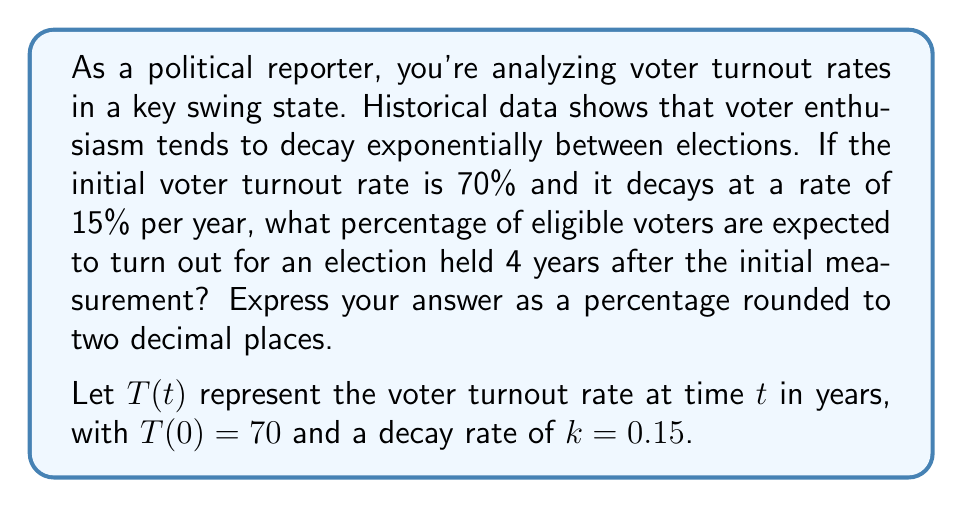Help me with this question. To solve this problem, we'll use the exponential decay function:

$$T(t) = T_0 e^{-kt}$$

Where:
$T(t)$ is the turnout rate at time $t$
$T_0$ is the initial turnout rate
$k$ is the decay rate
$t$ is the time in years

Given:
$T_0 = 70\%$
$k = 0.15$
$t = 4$ years

Step 1: Substitute the values into the exponential decay function:
$$T(4) = 70 e^{-0.15 \cdot 4}$$

Step 2: Simplify the exponent:
$$T(4) = 70 e^{-0.6}$$

Step 3: Calculate the value of $e^{-0.6}$:
$$e^{-0.6} \approx 0.5488$$

Step 4: Multiply by the initial turnout rate:
$$T(4) = 70 \cdot 0.5488 \approx 38.416$$

Step 5: Round to two decimal places and express as a percentage:
$$T(4) \approx 38.42\%$$
Answer: 38.42% 